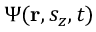Convert formula to latex. <formula><loc_0><loc_0><loc_500><loc_500>\Psi ( r , s _ { z } , t )</formula> 